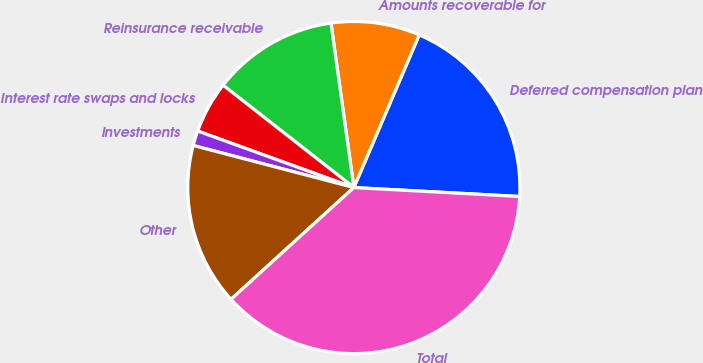Convert chart to OTSL. <chart><loc_0><loc_0><loc_500><loc_500><pie_chart><fcel>Deferred compensation plan<fcel>Amounts recoverable for<fcel>Reinsurance receivable<fcel>Interest rate swaps and locks<fcel>Investments<fcel>Other<fcel>Total<nl><fcel>19.42%<fcel>8.64%<fcel>12.23%<fcel>5.04%<fcel>1.45%<fcel>15.83%<fcel>37.39%<nl></chart> 